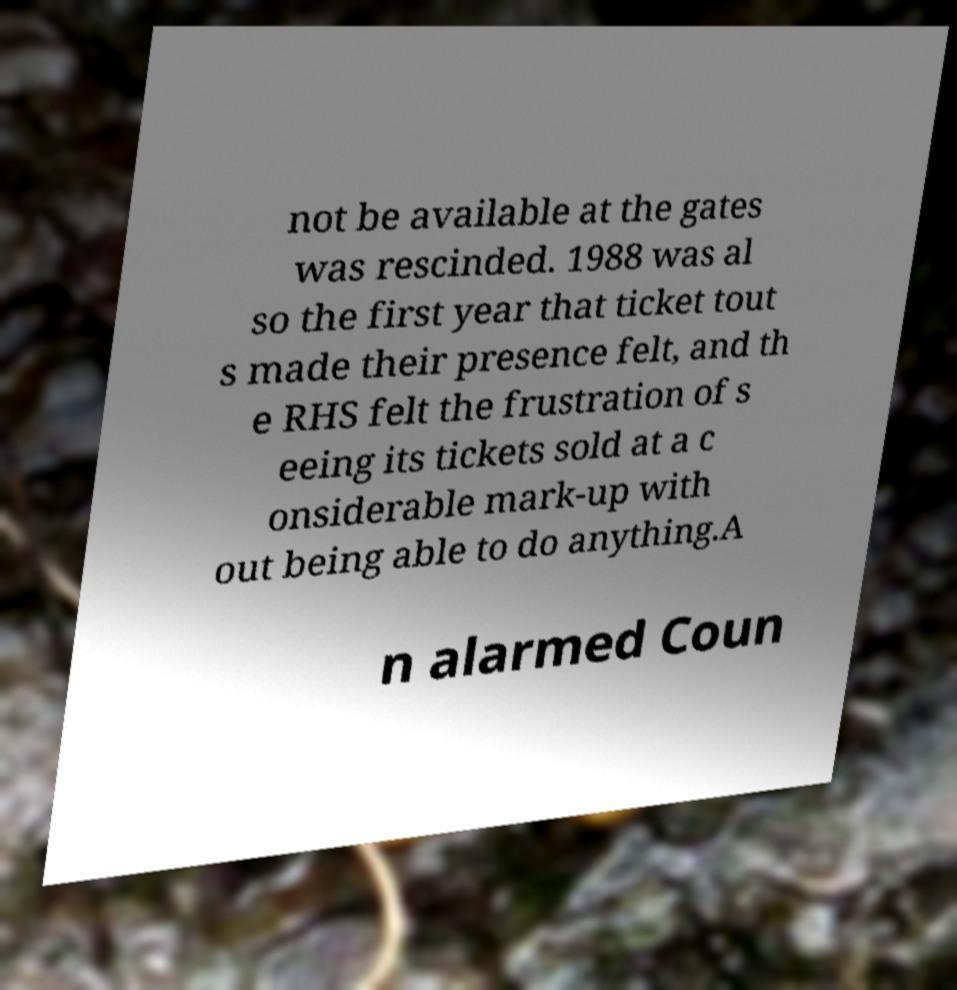For documentation purposes, I need the text within this image transcribed. Could you provide that? not be available at the gates was rescinded. 1988 was al so the first year that ticket tout s made their presence felt, and th e RHS felt the frustration of s eeing its tickets sold at a c onsiderable mark-up with out being able to do anything.A n alarmed Coun 